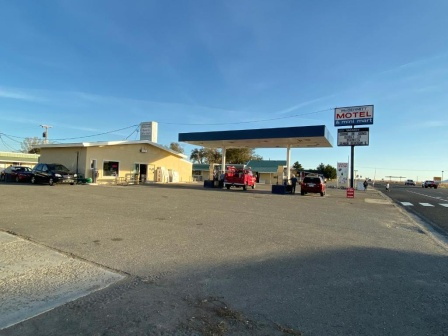What might be the reasons people are stopping at this particular gas station? Travelers could be stopping here for a variety of reasons. The gas station offers essential refueling for vehicles, which is crucial on long journeys. Additionally, the adjoining motel provides a convenient spot for rest and recovery after hours on the road. The location might also be a strategic stop for grabbing snacks and using restroom facilities, making this station a practical choice for both short stops and overnight stays. 